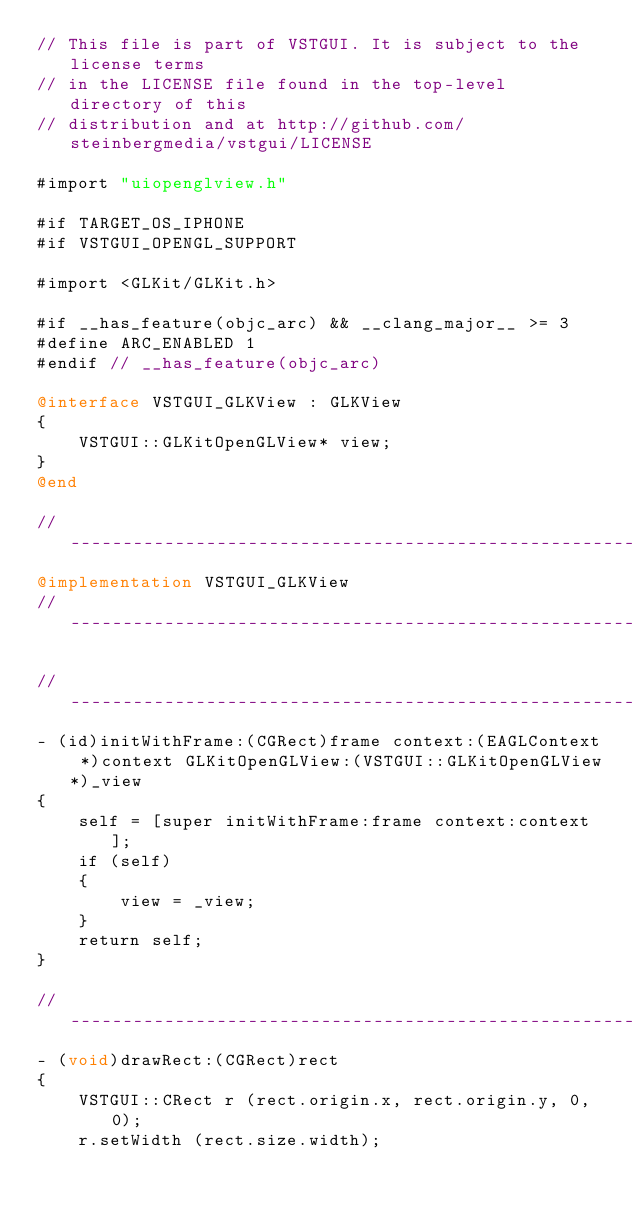Convert code to text. <code><loc_0><loc_0><loc_500><loc_500><_ObjectiveC_>// This file is part of VSTGUI. It is subject to the license terms 
// in the LICENSE file found in the top-level directory of this
// distribution and at http://github.com/steinbergmedia/vstgui/LICENSE

#import "uiopenglview.h"

#if TARGET_OS_IPHONE
#if VSTGUI_OPENGL_SUPPORT

#import <GLKit/GLKit.h>

#if __has_feature(objc_arc) && __clang_major__ >= 3
#define ARC_ENABLED 1
#endif // __has_feature(objc_arc)

@interface VSTGUI_GLKView : GLKView
{
	VSTGUI::GLKitOpenGLView* view;
}
@end

//-----------------------------------------------------------------------------
@implementation VSTGUI_GLKView
//-----------------------------------------------------------------------------

//-----------------------------------------------------------------------------
- (id)initWithFrame:(CGRect)frame context:(EAGLContext *)context GLKitOpenGLView:(VSTGUI::GLKitOpenGLView*)_view
{
	self = [super initWithFrame:frame context:context];
	if (self)
	{
		view = _view;
	}
	return self;
}

//-----------------------------------------------------------------------------
- (void)drawRect:(CGRect)rect
{
	VSTGUI::CRect r (rect.origin.x, rect.origin.y, 0, 0);
	r.setWidth (rect.size.width);</code> 